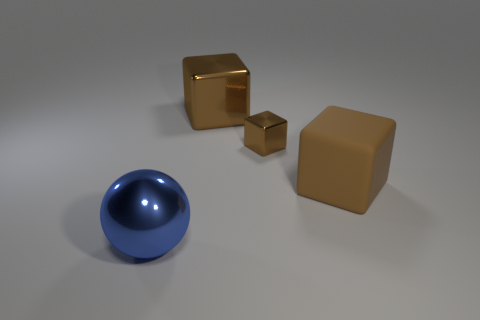Add 4 small metal objects. How many objects exist? 8 Subtract all balls. How many objects are left? 3 Add 2 small red metal balls. How many small red metal balls exist? 2 Subtract 0 yellow cubes. How many objects are left? 4 Subtract all cyan metallic things. Subtract all balls. How many objects are left? 3 Add 2 big blue things. How many big blue things are left? 3 